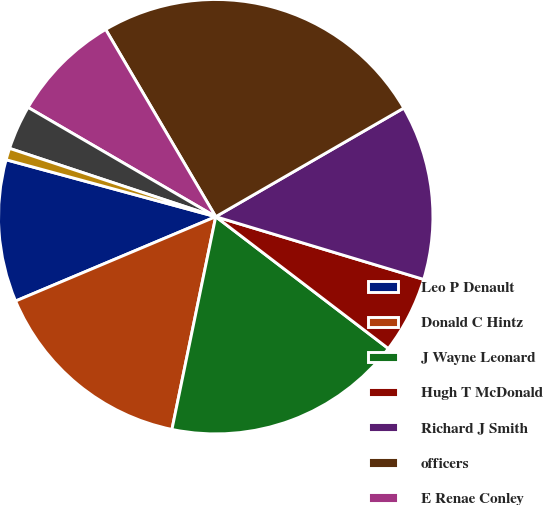Convert chart. <chart><loc_0><loc_0><loc_500><loc_500><pie_chart><fcel>Leo P Denault<fcel>Donald C Hintz<fcel>J Wayne Leonard<fcel>Hugh T McDonald<fcel>Richard J Smith<fcel>officers<fcel>E Renae Conley<fcel>Joseph F Domino<fcel>Carolyn C Shanks<nl><fcel>10.57%<fcel>15.42%<fcel>17.85%<fcel>5.72%<fcel>13.0%<fcel>25.12%<fcel>8.15%<fcel>3.3%<fcel>0.87%<nl></chart> 